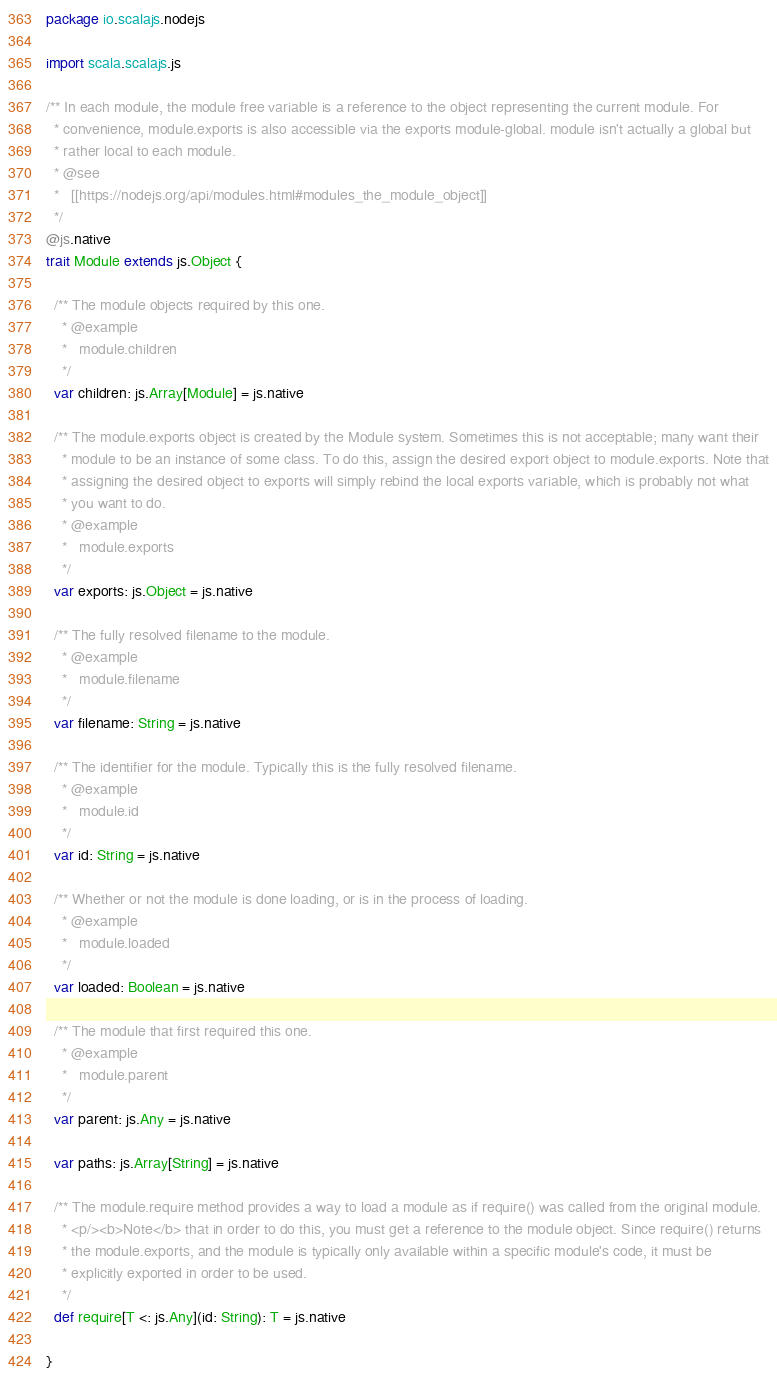<code> <loc_0><loc_0><loc_500><loc_500><_Scala_>package io.scalajs.nodejs

import scala.scalajs.js

/** In each module, the module free variable is a reference to the object representing the current module. For
  * convenience, module.exports is also accessible via the exports module-global. module isn't actually a global but
  * rather local to each module.
  * @see
  *   [[https://nodejs.org/api/modules.html#modules_the_module_object]]
  */
@js.native
trait Module extends js.Object {

  /** The module objects required by this one.
    * @example
    *   module.children
    */
  var children: js.Array[Module] = js.native

  /** The module.exports object is created by the Module system. Sometimes this is not acceptable; many want their
    * module to be an instance of some class. To do this, assign the desired export object to module.exports. Note that
    * assigning the desired object to exports will simply rebind the local exports variable, which is probably not what
    * you want to do.
    * @example
    *   module.exports
    */
  var exports: js.Object = js.native

  /** The fully resolved filename to the module.
    * @example
    *   module.filename
    */
  var filename: String = js.native

  /** The identifier for the module. Typically this is the fully resolved filename.
    * @example
    *   module.id
    */
  var id: String = js.native

  /** Whether or not the module is done loading, or is in the process of loading.
    * @example
    *   module.loaded
    */
  var loaded: Boolean = js.native

  /** The module that first required this one.
    * @example
    *   module.parent
    */
  var parent: js.Any = js.native

  var paths: js.Array[String] = js.native

  /** The module.require method provides a way to load a module as if require() was called from the original module.
    * <p/><b>Note</b> that in order to do this, you must get a reference to the module object. Since require() returns
    * the module.exports, and the module is typically only available within a specific module's code, it must be
    * explicitly exported in order to be used.
    */
  def require[T <: js.Any](id: String): T = js.native

}
</code> 